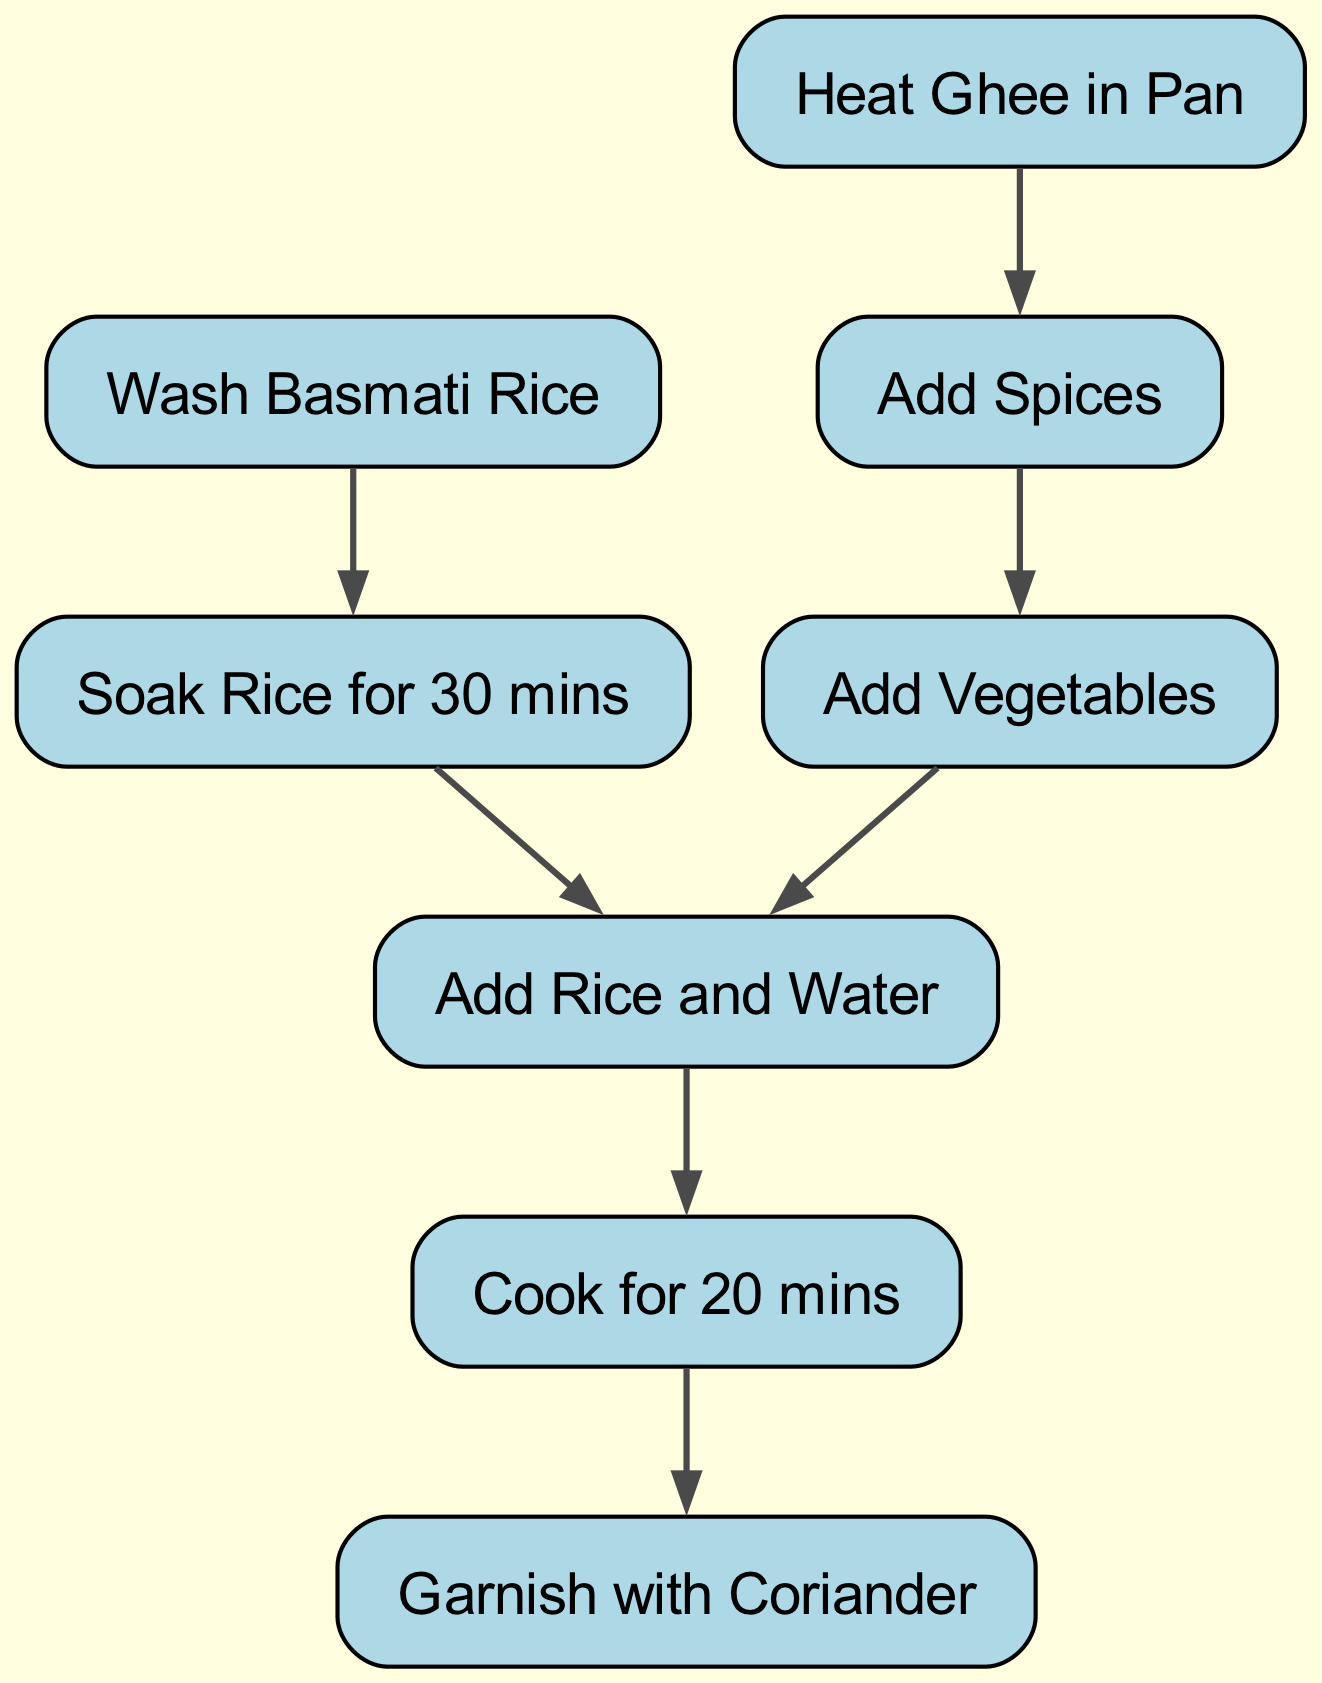What is the first step in the rice dish preparation? The diagram shows that the first step in the preparation is to "Wash Basmati Rice," as indicated by the node labeled with this action.
Answer: Wash Basmati Rice How many nodes are present in the diagram? There are 8 nodes present in the diagram, each representing a different step in the rice dish preparation process.
Answer: 8 Which step follows after soaking the rice? According to the diagram, after soaking the rice for 30 minutes (node 2), the next step is to "Add Rice and Water" (node 6). This is verified by the directed edge leading from node 2 to node 6.
Answer: Add Rice and Water What is the final step in the preparation process? The final step is to "Garnish with Coriander," which is indicated as the last node in the sequence because it follows after the cooking step.
Answer: Garnish with Coriander How many edges are there in total? The diagram contains 7 edges, which connect the 8 nodes, illustrating the flow of the preparation process. Each action leads to the next one, represented by these edges.
Answer: 7 What happens after heating ghee in the pan? After "Heating Ghee in Pan," the next actions are confirmed by the diagram, showing that "Add Spices" is the immediate next step to follow this action.
Answer: Add Spices If the rice is cooked for 20 minutes, which step comes next? Once the rice is cooked for 20 minutes (node 7), the flow indicates that the process concludes with the step “Garnish with Coriander” (node 8), as it's the next and final action to be taken.
Answer: Garnish with Coriander What ingredients are added after the spices? Following the addition of spices, the diagram specifies that "Add Vegetables" is the next step, as indicated by the directed edge leading from "Add Spices" to "Add Vegetables."
Answer: Add Vegetables 